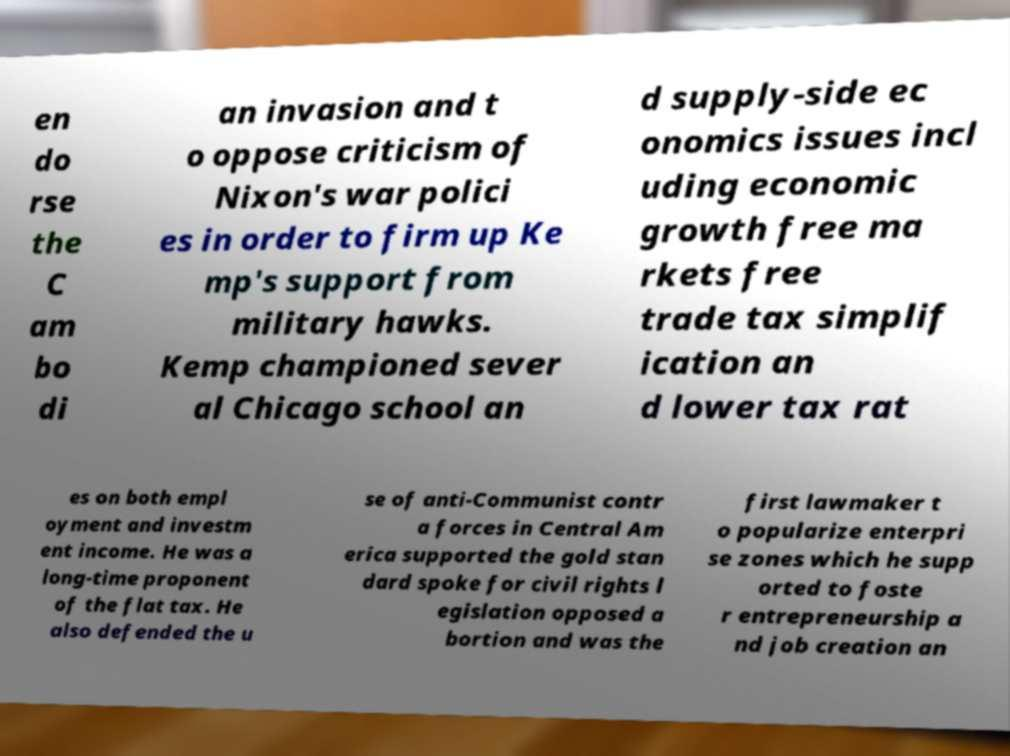For documentation purposes, I need the text within this image transcribed. Could you provide that? en do rse the C am bo di an invasion and t o oppose criticism of Nixon's war polici es in order to firm up Ke mp's support from military hawks. Kemp championed sever al Chicago school an d supply-side ec onomics issues incl uding economic growth free ma rkets free trade tax simplif ication an d lower tax rat es on both empl oyment and investm ent income. He was a long-time proponent of the flat tax. He also defended the u se of anti-Communist contr a forces in Central Am erica supported the gold stan dard spoke for civil rights l egislation opposed a bortion and was the first lawmaker t o popularize enterpri se zones which he supp orted to foste r entrepreneurship a nd job creation an 